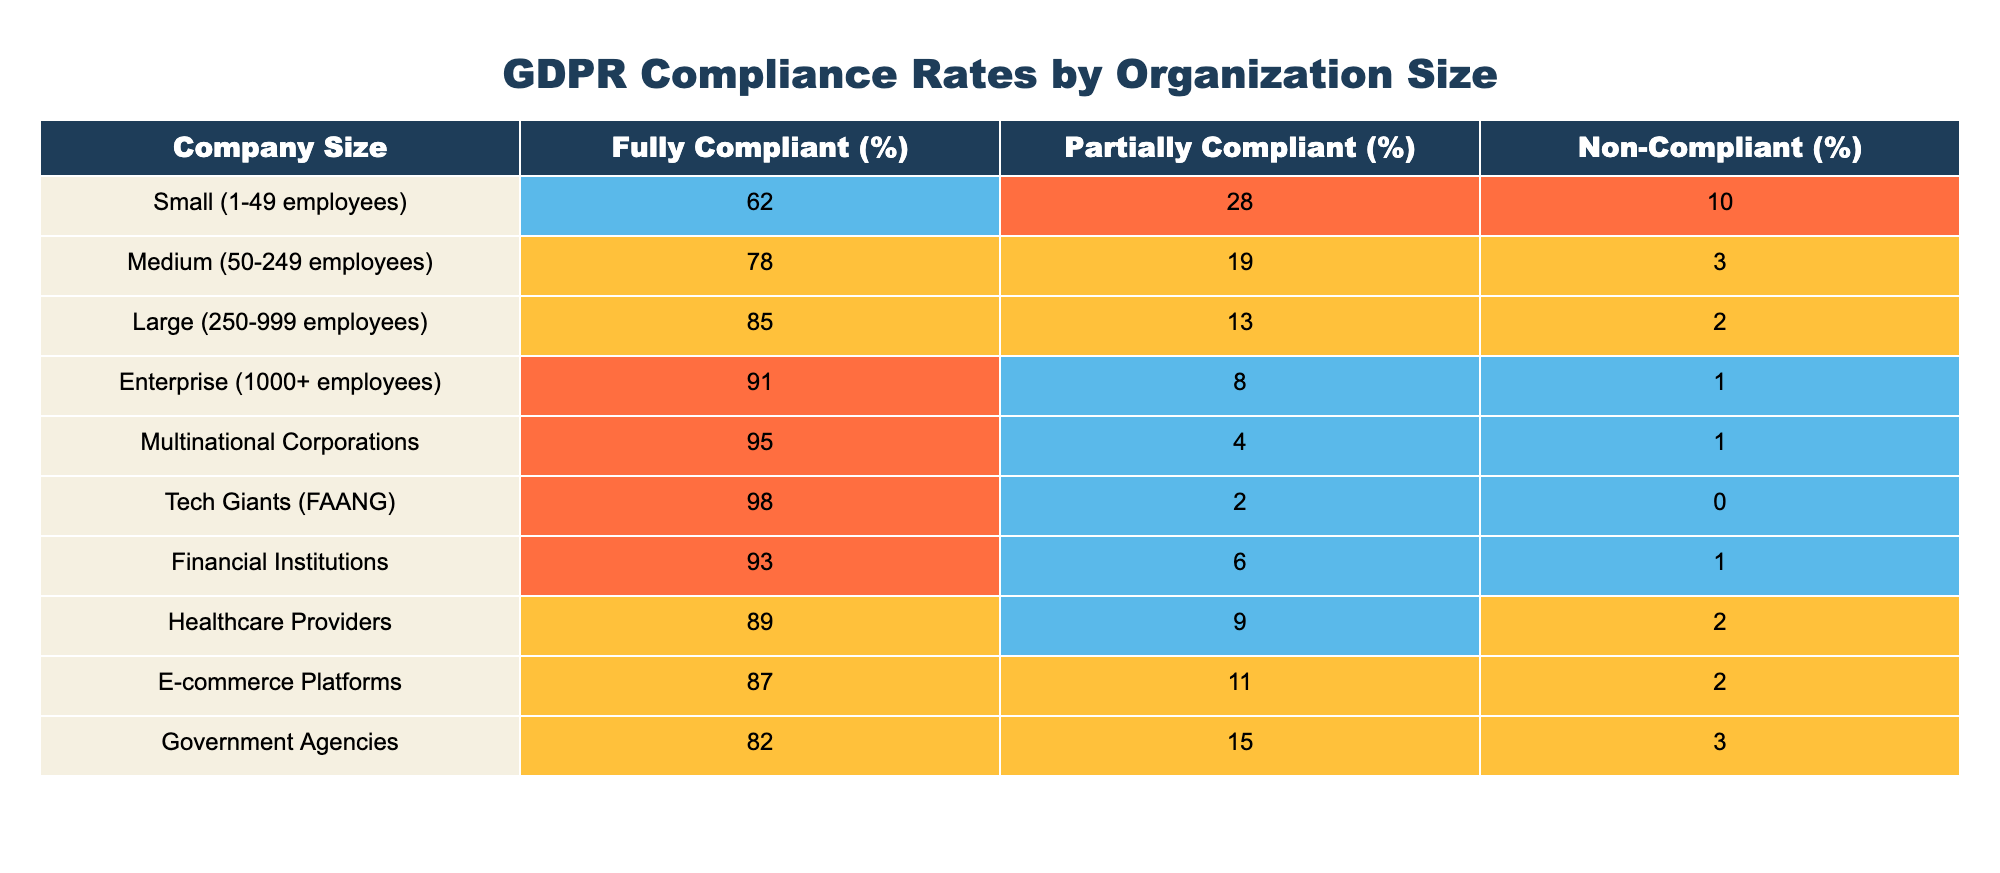What is the compliance rate for large organizations? The table shows that large organizations (250-999 employees) have a fully compliant rate of 85%.
Answer: 85% Which company size has the highest non-compliance rate? Looking at the non-compliant percentages, small organizations have a non-compliance rate of 10%, which is higher than the other categories listed.
Answer: Small (1-49 employees) What is the average fully compliant percentage for small and medium organizations? The fully compliant percentages for small organizations is 62% and for medium organizations is 78%. Adding these together gives 140%. Dividing by the number of groups (2), gives an average of 70%.
Answer: 70% Is the compliance rate of e-commerce platforms above or below 90%? The fully compliant rate for e-commerce platforms is 87%, which is below 90%.
Answer: Below What is the difference in fully compliant rates between tech giants and healthcare providers? The fully compliant rate for tech giants is 98% and for healthcare providers it is 89%. The difference is calculated by subtracting 89% from 98%, resulting in 9%.
Answer: 9% Do multinational corporations have a higher compliance rate than government agencies? The fully compliant rate for multinational corporations is 95%, while for government agencies it is 82%. Therefore, multinational corporations have a higher compliance rate.
Answer: Yes If we consider only medium and large organizations, what is the average partially compliant percentage? The partially compliant percentages for medium organizations is 19% and for large organizations is 13%. Adding these together gives 32%. To find the average, divide by 2, resulting in 16%.
Answer: 16% Which organization type has the lowest partially compliant percentage? Upon reviewing the partly compliant percentages, tech giants have the lowest at 2%.
Answer: Tech Giants (FAANG) Are financial institutions more compliant than healthcare providers? The fully compliant rate for financial institutions is 93%, and for healthcare providers, it is 89%. Since 93% is greater than 89%, financial institutions are indeed more compliant.
Answer: Yes 